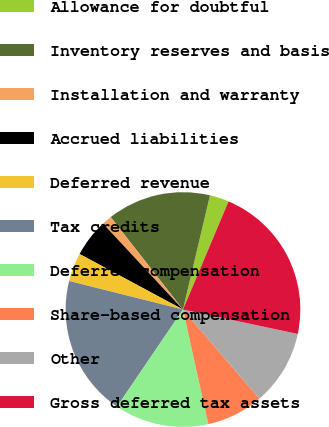Convert chart. <chart><loc_0><loc_0><loc_500><loc_500><pie_chart><fcel>Allowance for doubtful<fcel>Inventory reserves and basis<fcel>Installation and warranty<fcel>Accrued liabilities<fcel>Deferred revenue<fcel>Tax credits<fcel>Deferred compensation<fcel>Share-based compensation<fcel>Other<fcel>Gross deferred tax assets<nl><fcel>2.65%<fcel>14.26%<fcel>1.36%<fcel>5.23%<fcel>3.94%<fcel>19.41%<fcel>12.97%<fcel>7.81%<fcel>10.39%<fcel>21.99%<nl></chart> 